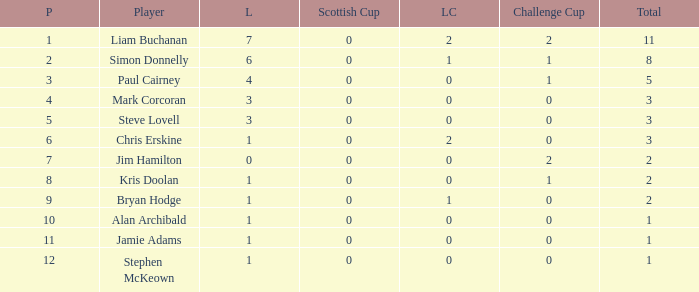What was the lowest number of points scored in the league cup? 0.0. 